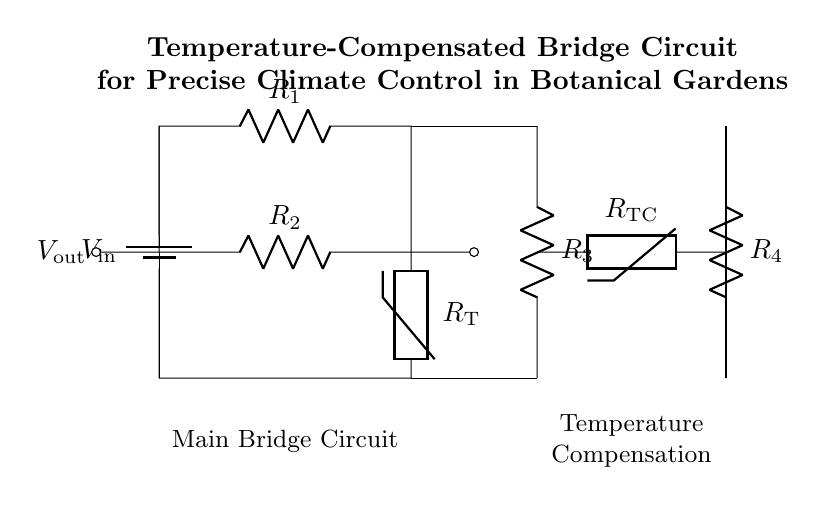What type of circuit is illustrated in the diagram? The diagram represents a bridge circuit, consisting of multiple resistors and thermistors arranged to measure voltage changes in response to temperature variations.
Answer: Bridge circuit What component is used for temperature sensing? The circuit includes a thermistor labeled as R_T, which changes its resistance based on temperature fluctuations, impacting the circuit's output.
Answer: Thermistor What is the purpose of R_3 in the circuit? R_3 serves to form part of the temperature compensation circuit, ensuring that temperature variations do not adversely affect the readings by stabilizing the circuit's output.
Answer: Temperature compensation How many resistors are present in the circuit? The circuit features a total of four resistors, R_1, R_2, R_3, and R_4, which collectively influence the voltage output across the bridge.
Answer: Four What is the output voltage measurement point labeled as? The output voltage is represented by V_out, indicating where the voltage measurement is taken to assess the circuit's response to changes in resistance due to temperature.
Answer: V_out What type of voltage is supplied by the battery? The battery connected at the start of the circuit supplies direct current voltage, V_in, which is essential for powering the bridge circuit and enabling the measurements.
Answer: Direct current What is the primary function of the temperature-compensated bridge circuit? The primary function is to ensure precise climate control by accurately measuring temperature changes, thus allowing for better management of environmental conditions in botanical gardens.
Answer: Precise climate control 